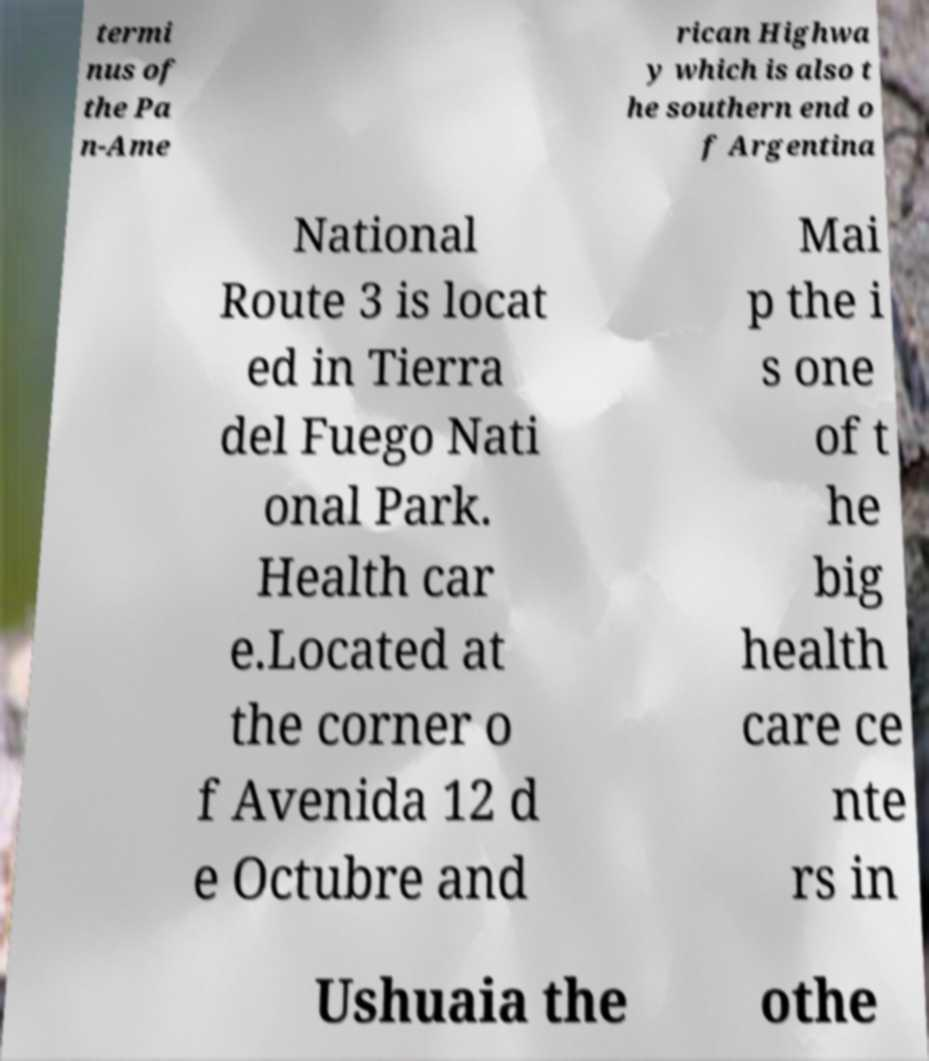Can you accurately transcribe the text from the provided image for me? termi nus of the Pa n-Ame rican Highwa y which is also t he southern end o f Argentina National Route 3 is locat ed in Tierra del Fuego Nati onal Park. Health car e.Located at the corner o f Avenida 12 d e Octubre and Mai p the i s one of t he big health care ce nte rs in Ushuaia the othe 